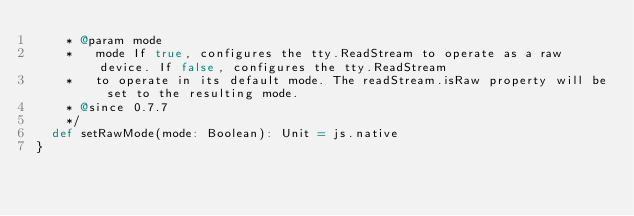<code> <loc_0><loc_0><loc_500><loc_500><_Scala_>    * @param mode
    *   mode If true, configures the tty.ReadStream to operate as a raw device. If false, configures the tty.ReadStream
    *   to operate in its default mode. The readStream.isRaw property will be set to the resulting mode.
    * @since 0.7.7
    */
  def setRawMode(mode: Boolean): Unit = js.native
}
</code> 